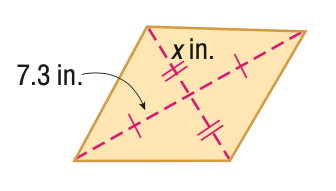Question: Find x. A = 96 in^2.
Choices:
A. 6.6
B. 6.9
C. 13.2
D. 13.7
Answer with the letter. Answer: A 